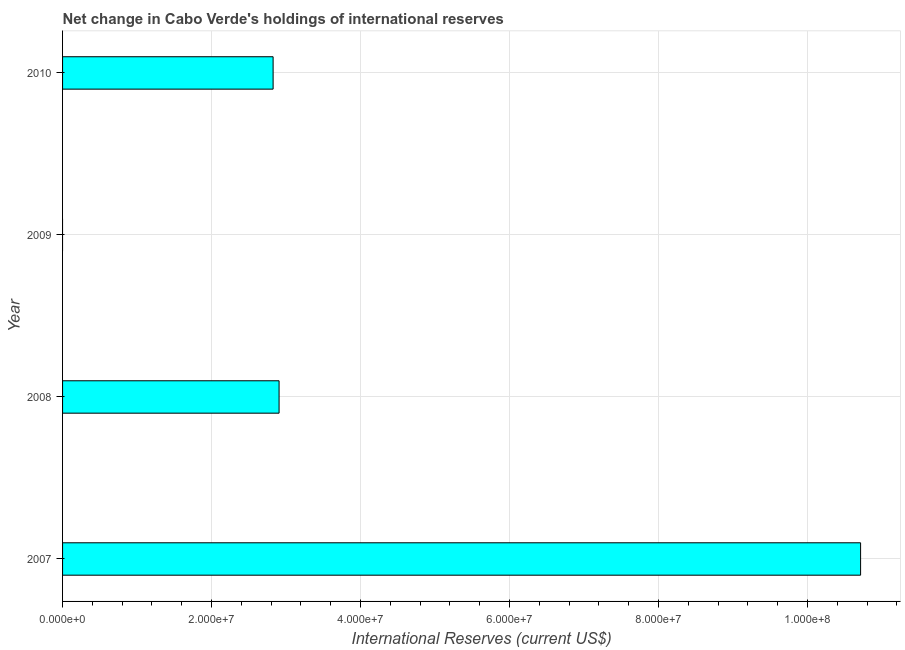Does the graph contain any zero values?
Keep it short and to the point. Yes. Does the graph contain grids?
Keep it short and to the point. Yes. What is the title of the graph?
Provide a short and direct response. Net change in Cabo Verde's holdings of international reserves. What is the label or title of the X-axis?
Make the answer very short. International Reserves (current US$). What is the reserves and related items in 2007?
Give a very brief answer. 1.07e+08. Across all years, what is the maximum reserves and related items?
Make the answer very short. 1.07e+08. Across all years, what is the minimum reserves and related items?
Your response must be concise. 0. In which year was the reserves and related items maximum?
Offer a terse response. 2007. What is the sum of the reserves and related items?
Keep it short and to the point. 1.64e+08. What is the difference between the reserves and related items in 2007 and 2008?
Ensure brevity in your answer.  7.81e+07. What is the average reserves and related items per year?
Provide a succinct answer. 4.11e+07. What is the median reserves and related items?
Provide a short and direct response. 2.87e+07. In how many years, is the reserves and related items greater than 88000000 US$?
Your answer should be very brief. 1. What is the ratio of the reserves and related items in 2007 to that in 2010?
Ensure brevity in your answer.  3.79. What is the difference between the highest and the second highest reserves and related items?
Make the answer very short. 7.81e+07. Is the sum of the reserves and related items in 2008 and 2010 greater than the maximum reserves and related items across all years?
Your answer should be compact. No. What is the difference between the highest and the lowest reserves and related items?
Provide a short and direct response. 1.07e+08. How many years are there in the graph?
Keep it short and to the point. 4. Are the values on the major ticks of X-axis written in scientific E-notation?
Offer a terse response. Yes. What is the International Reserves (current US$) of 2007?
Your answer should be very brief. 1.07e+08. What is the International Reserves (current US$) in 2008?
Your answer should be compact. 2.91e+07. What is the International Reserves (current US$) of 2009?
Your answer should be compact. 0. What is the International Reserves (current US$) of 2010?
Offer a very short reply. 2.83e+07. What is the difference between the International Reserves (current US$) in 2007 and 2008?
Offer a very short reply. 7.81e+07. What is the difference between the International Reserves (current US$) in 2007 and 2010?
Your response must be concise. 7.89e+07. What is the difference between the International Reserves (current US$) in 2008 and 2010?
Your response must be concise. 7.99e+05. What is the ratio of the International Reserves (current US$) in 2007 to that in 2008?
Provide a succinct answer. 3.69. What is the ratio of the International Reserves (current US$) in 2007 to that in 2010?
Ensure brevity in your answer.  3.79. What is the ratio of the International Reserves (current US$) in 2008 to that in 2010?
Your answer should be very brief. 1.03. 